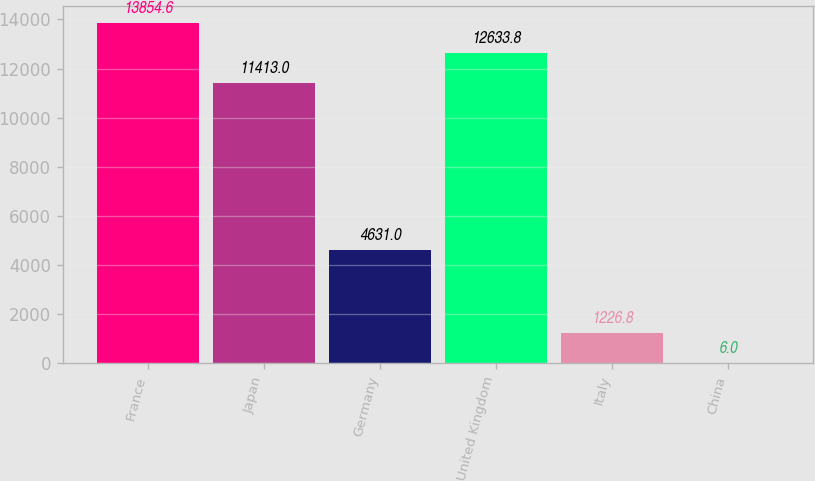Convert chart to OTSL. <chart><loc_0><loc_0><loc_500><loc_500><bar_chart><fcel>France<fcel>Japan<fcel>Germany<fcel>United Kingdom<fcel>Italy<fcel>China<nl><fcel>13854.6<fcel>11413<fcel>4631<fcel>12633.8<fcel>1226.8<fcel>6<nl></chart> 